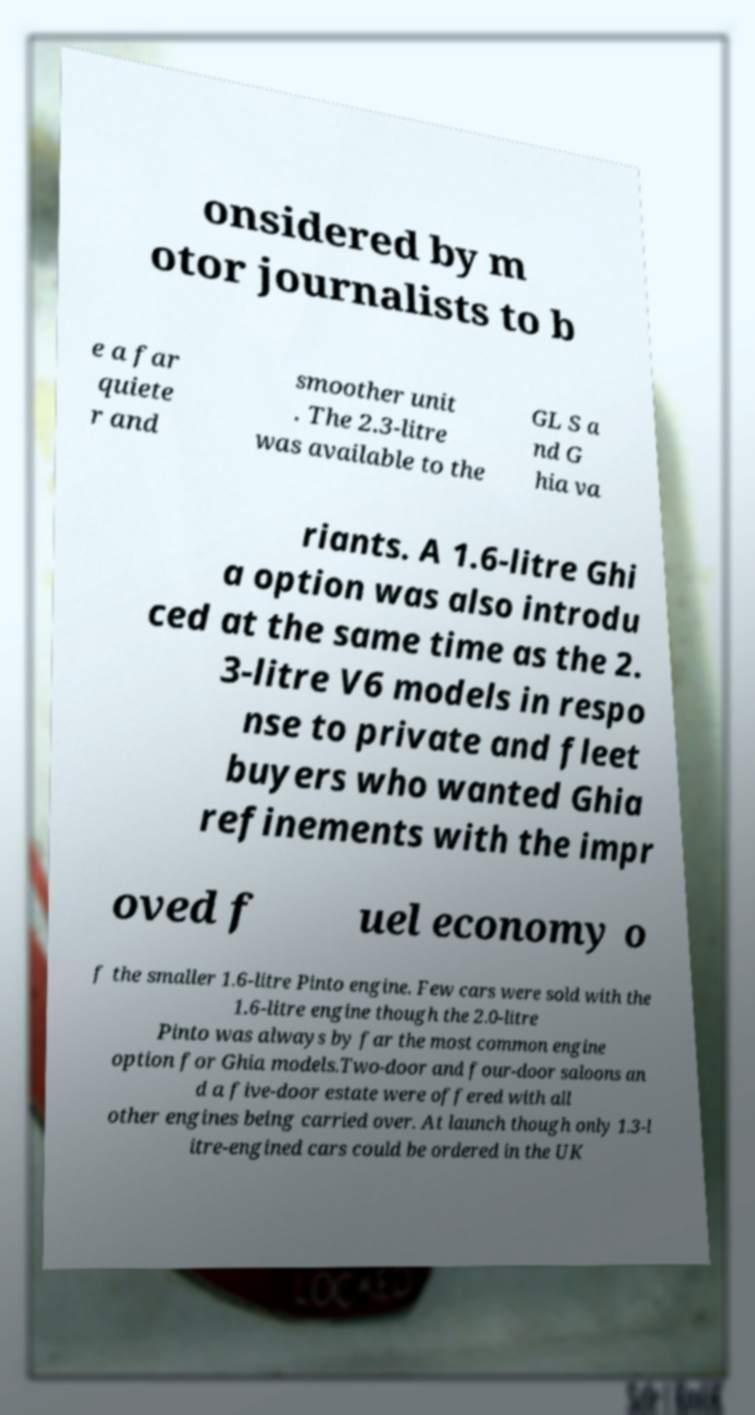For documentation purposes, I need the text within this image transcribed. Could you provide that? onsidered by m otor journalists to b e a far quiete r and smoother unit . The 2.3-litre was available to the GL S a nd G hia va riants. A 1.6-litre Ghi a option was also introdu ced at the same time as the 2. 3-litre V6 models in respo nse to private and fleet buyers who wanted Ghia refinements with the impr oved f uel economy o f the smaller 1.6-litre Pinto engine. Few cars were sold with the 1.6-litre engine though the 2.0-litre Pinto was always by far the most common engine option for Ghia models.Two-door and four-door saloons an d a five-door estate were offered with all other engines being carried over. At launch though only 1.3-l itre-engined cars could be ordered in the UK 